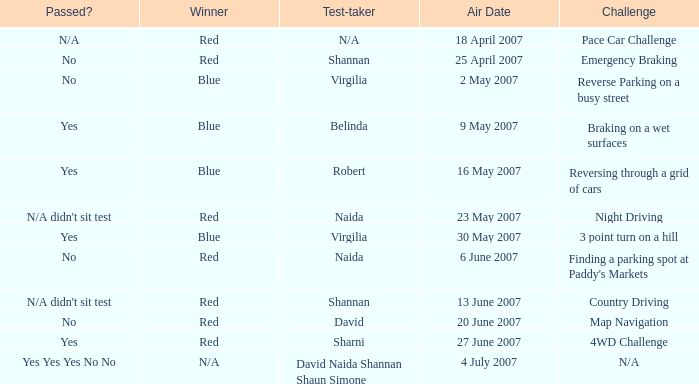On which air date was Robert the test-taker? 16 May 2007. 